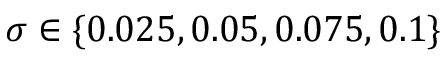<formula> <loc_0><loc_0><loc_500><loc_500>\sigma \in \{ 0 . 0 2 5 , 0 . 0 5 , 0 . 0 7 5 , 0 . 1 \}</formula> 